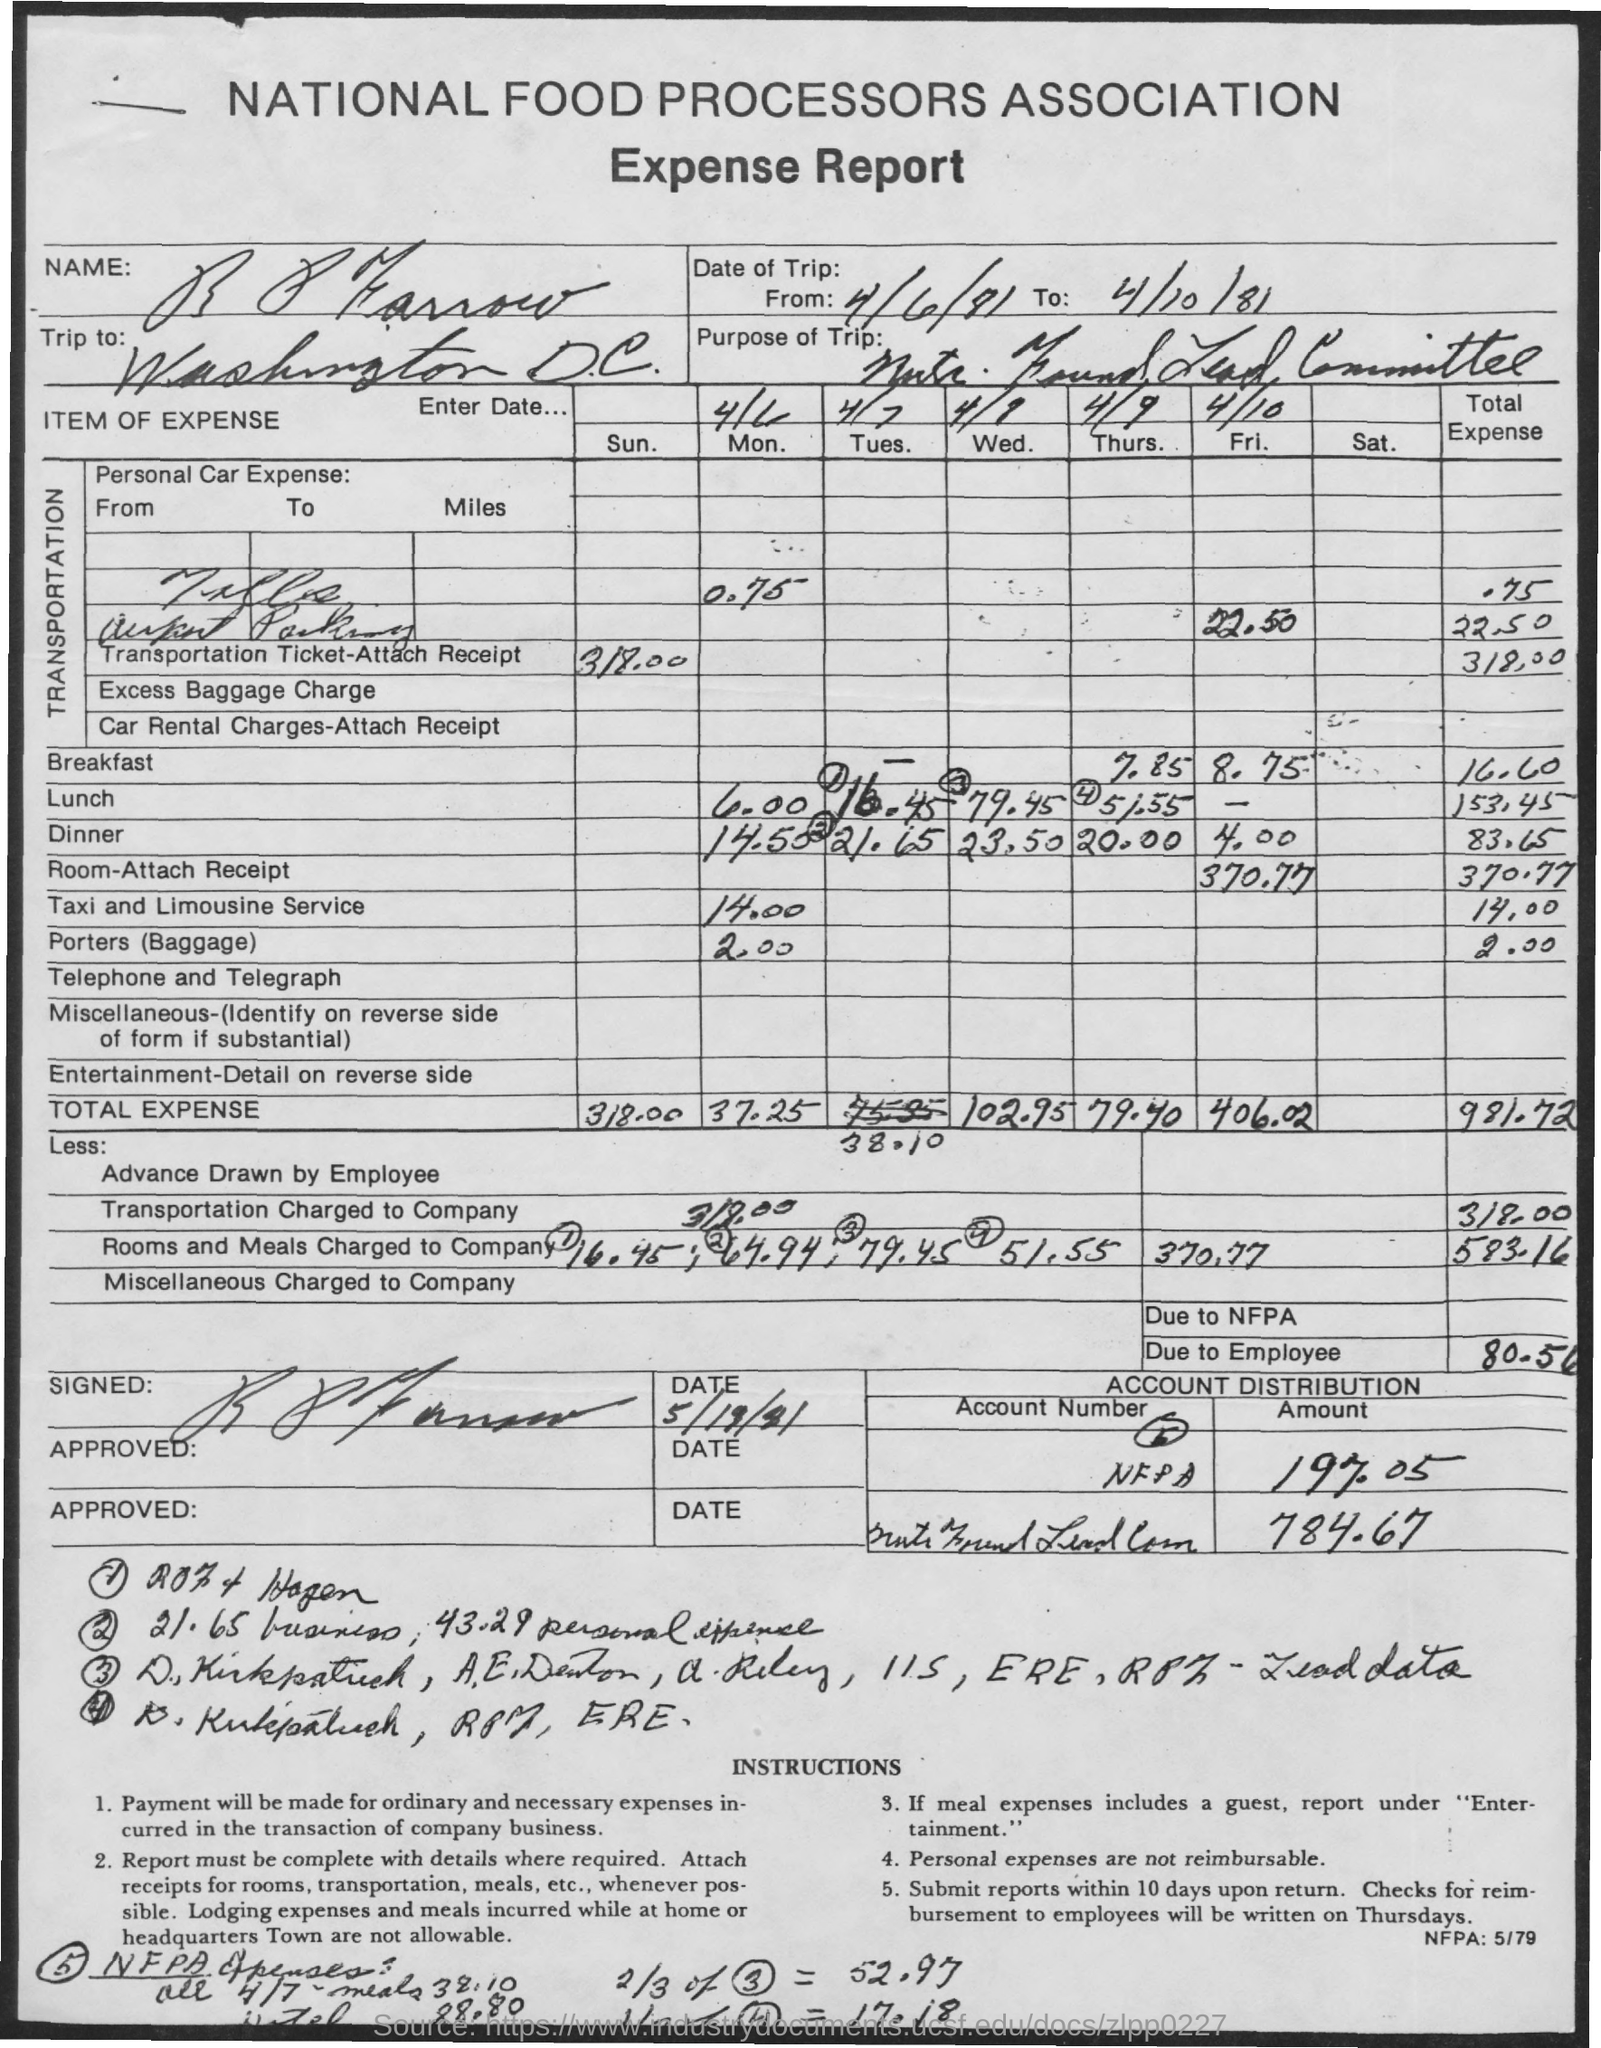Identify some key points in this picture. The first title in the document is "National Food Processors Association. The second title in the document is 'expense report.' The destination of the trip is Washington D.C. The total expense for the taxi and limousine service is 14.00. The total expense for breakfast is 16.60. 